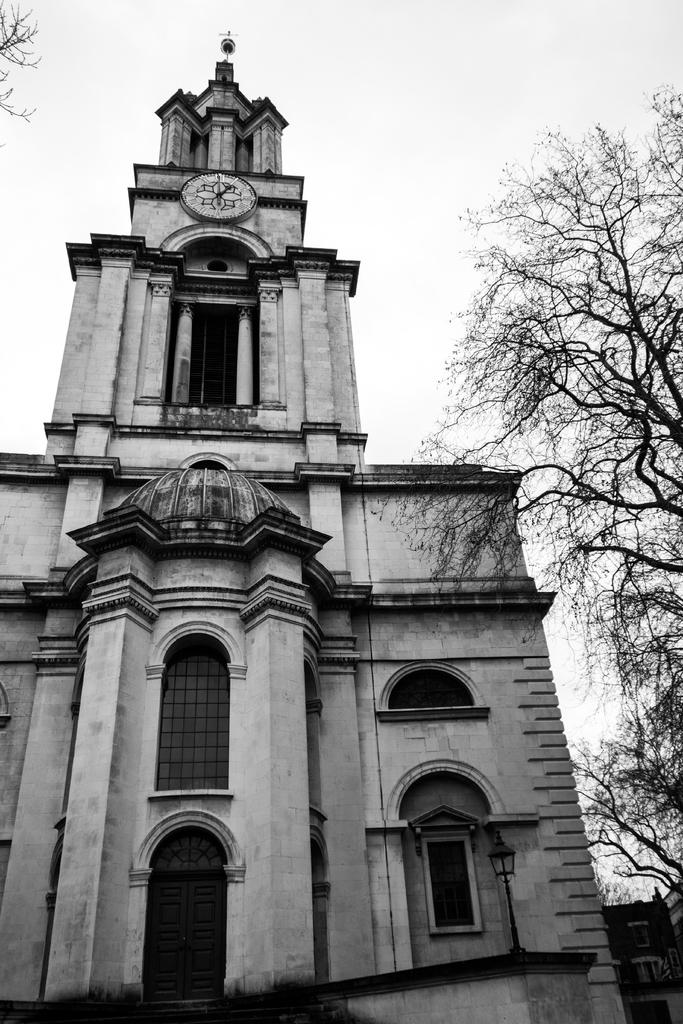What type of structure is in the image? There is a historical building in the image. What is located near the historical building? There is a tree beside the historical building. How does the tree appear in the image? The tree appears to be dried. What can be seen in the background of the image? The sky is visible in the background of the image. What type of pear is being used to join the historical building and the tree in the image? There is no pear present in the image, nor is there any indication that the building and tree are being joined together. 